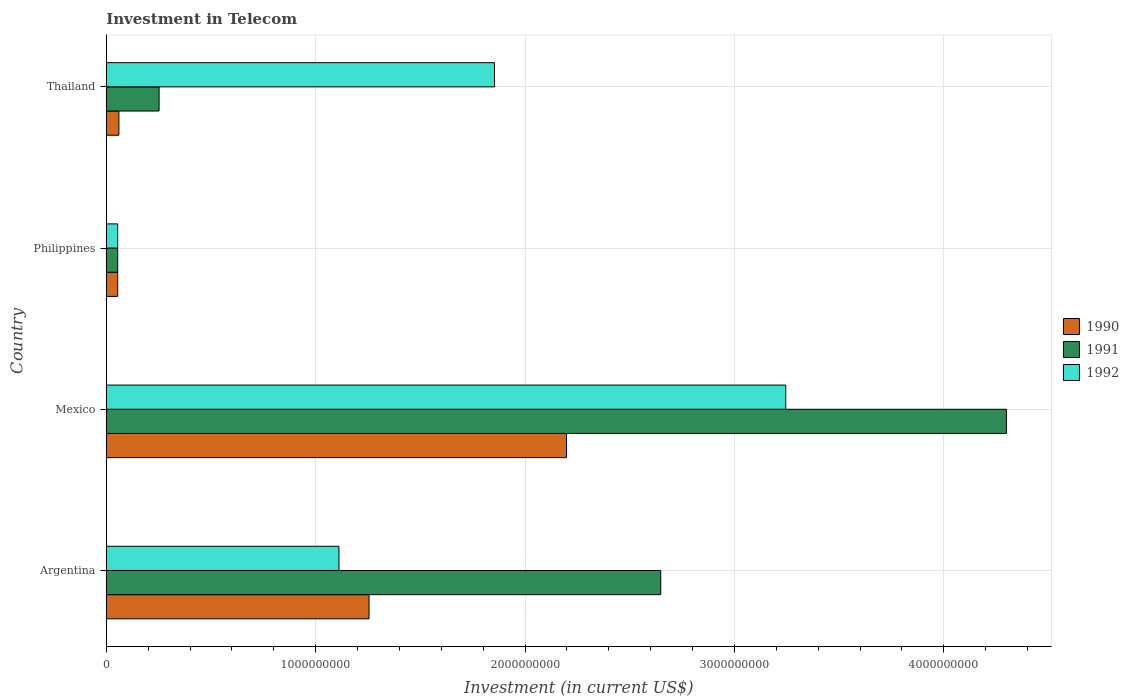How many different coloured bars are there?
Provide a succinct answer. 3. Are the number of bars on each tick of the Y-axis equal?
Keep it short and to the point. Yes. How many bars are there on the 2nd tick from the bottom?
Your response must be concise. 3. What is the label of the 1st group of bars from the top?
Give a very brief answer. Thailand. What is the amount invested in telecom in 1990 in Mexico?
Keep it short and to the point. 2.20e+09. Across all countries, what is the maximum amount invested in telecom in 1991?
Ensure brevity in your answer.  4.30e+09. Across all countries, what is the minimum amount invested in telecom in 1991?
Provide a short and direct response. 5.42e+07. In which country was the amount invested in telecom in 1990 maximum?
Make the answer very short. Mexico. What is the total amount invested in telecom in 1991 in the graph?
Offer a very short reply. 7.25e+09. What is the difference between the amount invested in telecom in 1992 in Mexico and that in Thailand?
Ensure brevity in your answer.  1.39e+09. What is the difference between the amount invested in telecom in 1992 in Argentina and the amount invested in telecom in 1991 in Mexico?
Your answer should be very brief. -3.19e+09. What is the average amount invested in telecom in 1990 per country?
Provide a succinct answer. 8.92e+08. What is the difference between the amount invested in telecom in 1992 and amount invested in telecom in 1990 in Philippines?
Your answer should be compact. 0. What is the ratio of the amount invested in telecom in 1992 in Argentina to that in Mexico?
Ensure brevity in your answer.  0.34. Is the difference between the amount invested in telecom in 1992 in Philippines and Thailand greater than the difference between the amount invested in telecom in 1990 in Philippines and Thailand?
Your answer should be very brief. No. What is the difference between the highest and the second highest amount invested in telecom in 1991?
Your answer should be compact. 1.65e+09. What is the difference between the highest and the lowest amount invested in telecom in 1990?
Give a very brief answer. 2.14e+09. In how many countries, is the amount invested in telecom in 1992 greater than the average amount invested in telecom in 1992 taken over all countries?
Your response must be concise. 2. What does the 1st bar from the bottom in Philippines represents?
Offer a very short reply. 1990. Are all the bars in the graph horizontal?
Ensure brevity in your answer.  Yes. How many countries are there in the graph?
Keep it short and to the point. 4. Are the values on the major ticks of X-axis written in scientific E-notation?
Keep it short and to the point. No. Does the graph contain any zero values?
Your answer should be compact. No. Does the graph contain grids?
Make the answer very short. Yes. Where does the legend appear in the graph?
Offer a terse response. Center right. How are the legend labels stacked?
Provide a short and direct response. Vertical. What is the title of the graph?
Make the answer very short. Investment in Telecom. Does "1963" appear as one of the legend labels in the graph?
Provide a succinct answer. No. What is the label or title of the X-axis?
Provide a short and direct response. Investment (in current US$). What is the label or title of the Y-axis?
Your response must be concise. Country. What is the Investment (in current US$) of 1990 in Argentina?
Your answer should be compact. 1.25e+09. What is the Investment (in current US$) of 1991 in Argentina?
Provide a short and direct response. 2.65e+09. What is the Investment (in current US$) in 1992 in Argentina?
Make the answer very short. 1.11e+09. What is the Investment (in current US$) in 1990 in Mexico?
Your response must be concise. 2.20e+09. What is the Investment (in current US$) of 1991 in Mexico?
Give a very brief answer. 4.30e+09. What is the Investment (in current US$) of 1992 in Mexico?
Offer a terse response. 3.24e+09. What is the Investment (in current US$) in 1990 in Philippines?
Keep it short and to the point. 5.42e+07. What is the Investment (in current US$) in 1991 in Philippines?
Provide a short and direct response. 5.42e+07. What is the Investment (in current US$) in 1992 in Philippines?
Your answer should be compact. 5.42e+07. What is the Investment (in current US$) of 1990 in Thailand?
Give a very brief answer. 6.00e+07. What is the Investment (in current US$) of 1991 in Thailand?
Your answer should be very brief. 2.52e+08. What is the Investment (in current US$) in 1992 in Thailand?
Keep it short and to the point. 1.85e+09. Across all countries, what is the maximum Investment (in current US$) in 1990?
Offer a terse response. 2.20e+09. Across all countries, what is the maximum Investment (in current US$) of 1991?
Provide a short and direct response. 4.30e+09. Across all countries, what is the maximum Investment (in current US$) of 1992?
Your answer should be very brief. 3.24e+09. Across all countries, what is the minimum Investment (in current US$) of 1990?
Your answer should be compact. 5.42e+07. Across all countries, what is the minimum Investment (in current US$) of 1991?
Ensure brevity in your answer.  5.42e+07. Across all countries, what is the minimum Investment (in current US$) of 1992?
Offer a very short reply. 5.42e+07. What is the total Investment (in current US$) of 1990 in the graph?
Offer a terse response. 3.57e+09. What is the total Investment (in current US$) in 1991 in the graph?
Your answer should be compact. 7.25e+09. What is the total Investment (in current US$) of 1992 in the graph?
Provide a short and direct response. 6.26e+09. What is the difference between the Investment (in current US$) in 1990 in Argentina and that in Mexico?
Provide a short and direct response. -9.43e+08. What is the difference between the Investment (in current US$) of 1991 in Argentina and that in Mexico?
Your answer should be compact. -1.65e+09. What is the difference between the Investment (in current US$) of 1992 in Argentina and that in Mexico?
Your response must be concise. -2.13e+09. What is the difference between the Investment (in current US$) of 1990 in Argentina and that in Philippines?
Keep it short and to the point. 1.20e+09. What is the difference between the Investment (in current US$) in 1991 in Argentina and that in Philippines?
Provide a short and direct response. 2.59e+09. What is the difference between the Investment (in current US$) in 1992 in Argentina and that in Philippines?
Your answer should be compact. 1.06e+09. What is the difference between the Investment (in current US$) of 1990 in Argentina and that in Thailand?
Ensure brevity in your answer.  1.19e+09. What is the difference between the Investment (in current US$) in 1991 in Argentina and that in Thailand?
Provide a succinct answer. 2.40e+09. What is the difference between the Investment (in current US$) of 1992 in Argentina and that in Thailand?
Your answer should be very brief. -7.43e+08. What is the difference between the Investment (in current US$) in 1990 in Mexico and that in Philippines?
Your answer should be compact. 2.14e+09. What is the difference between the Investment (in current US$) in 1991 in Mexico and that in Philippines?
Your answer should be very brief. 4.24e+09. What is the difference between the Investment (in current US$) of 1992 in Mexico and that in Philippines?
Provide a succinct answer. 3.19e+09. What is the difference between the Investment (in current US$) in 1990 in Mexico and that in Thailand?
Offer a terse response. 2.14e+09. What is the difference between the Investment (in current US$) of 1991 in Mexico and that in Thailand?
Offer a terse response. 4.05e+09. What is the difference between the Investment (in current US$) in 1992 in Mexico and that in Thailand?
Your answer should be compact. 1.39e+09. What is the difference between the Investment (in current US$) in 1990 in Philippines and that in Thailand?
Your answer should be compact. -5.80e+06. What is the difference between the Investment (in current US$) in 1991 in Philippines and that in Thailand?
Your response must be concise. -1.98e+08. What is the difference between the Investment (in current US$) in 1992 in Philippines and that in Thailand?
Offer a very short reply. -1.80e+09. What is the difference between the Investment (in current US$) in 1990 in Argentina and the Investment (in current US$) in 1991 in Mexico?
Ensure brevity in your answer.  -3.04e+09. What is the difference between the Investment (in current US$) of 1990 in Argentina and the Investment (in current US$) of 1992 in Mexico?
Provide a succinct answer. -1.99e+09. What is the difference between the Investment (in current US$) of 1991 in Argentina and the Investment (in current US$) of 1992 in Mexico?
Offer a very short reply. -5.97e+08. What is the difference between the Investment (in current US$) in 1990 in Argentina and the Investment (in current US$) in 1991 in Philippines?
Provide a short and direct response. 1.20e+09. What is the difference between the Investment (in current US$) of 1990 in Argentina and the Investment (in current US$) of 1992 in Philippines?
Make the answer very short. 1.20e+09. What is the difference between the Investment (in current US$) of 1991 in Argentina and the Investment (in current US$) of 1992 in Philippines?
Your answer should be compact. 2.59e+09. What is the difference between the Investment (in current US$) of 1990 in Argentina and the Investment (in current US$) of 1991 in Thailand?
Your answer should be very brief. 1.00e+09. What is the difference between the Investment (in current US$) of 1990 in Argentina and the Investment (in current US$) of 1992 in Thailand?
Offer a terse response. -5.99e+08. What is the difference between the Investment (in current US$) in 1991 in Argentina and the Investment (in current US$) in 1992 in Thailand?
Your response must be concise. 7.94e+08. What is the difference between the Investment (in current US$) of 1990 in Mexico and the Investment (in current US$) of 1991 in Philippines?
Give a very brief answer. 2.14e+09. What is the difference between the Investment (in current US$) of 1990 in Mexico and the Investment (in current US$) of 1992 in Philippines?
Ensure brevity in your answer.  2.14e+09. What is the difference between the Investment (in current US$) of 1991 in Mexico and the Investment (in current US$) of 1992 in Philippines?
Offer a terse response. 4.24e+09. What is the difference between the Investment (in current US$) of 1990 in Mexico and the Investment (in current US$) of 1991 in Thailand?
Offer a terse response. 1.95e+09. What is the difference between the Investment (in current US$) in 1990 in Mexico and the Investment (in current US$) in 1992 in Thailand?
Provide a short and direct response. 3.44e+08. What is the difference between the Investment (in current US$) of 1991 in Mexico and the Investment (in current US$) of 1992 in Thailand?
Keep it short and to the point. 2.44e+09. What is the difference between the Investment (in current US$) of 1990 in Philippines and the Investment (in current US$) of 1991 in Thailand?
Provide a succinct answer. -1.98e+08. What is the difference between the Investment (in current US$) in 1990 in Philippines and the Investment (in current US$) in 1992 in Thailand?
Ensure brevity in your answer.  -1.80e+09. What is the difference between the Investment (in current US$) in 1991 in Philippines and the Investment (in current US$) in 1992 in Thailand?
Your response must be concise. -1.80e+09. What is the average Investment (in current US$) in 1990 per country?
Offer a very short reply. 8.92e+08. What is the average Investment (in current US$) in 1991 per country?
Your answer should be compact. 1.81e+09. What is the average Investment (in current US$) of 1992 per country?
Your answer should be very brief. 1.57e+09. What is the difference between the Investment (in current US$) of 1990 and Investment (in current US$) of 1991 in Argentina?
Your answer should be very brief. -1.39e+09. What is the difference between the Investment (in current US$) in 1990 and Investment (in current US$) in 1992 in Argentina?
Your answer should be very brief. 1.44e+08. What is the difference between the Investment (in current US$) of 1991 and Investment (in current US$) of 1992 in Argentina?
Make the answer very short. 1.54e+09. What is the difference between the Investment (in current US$) in 1990 and Investment (in current US$) in 1991 in Mexico?
Offer a very short reply. -2.10e+09. What is the difference between the Investment (in current US$) in 1990 and Investment (in current US$) in 1992 in Mexico?
Offer a terse response. -1.05e+09. What is the difference between the Investment (in current US$) of 1991 and Investment (in current US$) of 1992 in Mexico?
Keep it short and to the point. 1.05e+09. What is the difference between the Investment (in current US$) in 1990 and Investment (in current US$) in 1992 in Philippines?
Your answer should be compact. 0. What is the difference between the Investment (in current US$) in 1990 and Investment (in current US$) in 1991 in Thailand?
Keep it short and to the point. -1.92e+08. What is the difference between the Investment (in current US$) of 1990 and Investment (in current US$) of 1992 in Thailand?
Keep it short and to the point. -1.79e+09. What is the difference between the Investment (in current US$) in 1991 and Investment (in current US$) in 1992 in Thailand?
Provide a short and direct response. -1.60e+09. What is the ratio of the Investment (in current US$) in 1990 in Argentina to that in Mexico?
Offer a terse response. 0.57. What is the ratio of the Investment (in current US$) in 1991 in Argentina to that in Mexico?
Give a very brief answer. 0.62. What is the ratio of the Investment (in current US$) in 1992 in Argentina to that in Mexico?
Make the answer very short. 0.34. What is the ratio of the Investment (in current US$) of 1990 in Argentina to that in Philippines?
Your answer should be very brief. 23.15. What is the ratio of the Investment (in current US$) of 1991 in Argentina to that in Philippines?
Give a very brief answer. 48.86. What is the ratio of the Investment (in current US$) of 1992 in Argentina to that in Philippines?
Your answer should be compact. 20.5. What is the ratio of the Investment (in current US$) of 1990 in Argentina to that in Thailand?
Offer a terse response. 20.91. What is the ratio of the Investment (in current US$) of 1991 in Argentina to that in Thailand?
Ensure brevity in your answer.  10.51. What is the ratio of the Investment (in current US$) in 1992 in Argentina to that in Thailand?
Offer a terse response. 0.6. What is the ratio of the Investment (in current US$) of 1990 in Mexico to that in Philippines?
Make the answer very short. 40.55. What is the ratio of the Investment (in current US$) of 1991 in Mexico to that in Philippines?
Your answer should be very brief. 79.32. What is the ratio of the Investment (in current US$) of 1992 in Mexico to that in Philippines?
Offer a terse response. 59.87. What is the ratio of the Investment (in current US$) of 1990 in Mexico to that in Thailand?
Provide a short and direct response. 36.63. What is the ratio of the Investment (in current US$) of 1991 in Mexico to that in Thailand?
Offer a terse response. 17.06. What is the ratio of the Investment (in current US$) in 1992 in Mexico to that in Thailand?
Offer a terse response. 1.75. What is the ratio of the Investment (in current US$) of 1990 in Philippines to that in Thailand?
Keep it short and to the point. 0.9. What is the ratio of the Investment (in current US$) of 1991 in Philippines to that in Thailand?
Provide a succinct answer. 0.22. What is the ratio of the Investment (in current US$) of 1992 in Philippines to that in Thailand?
Offer a very short reply. 0.03. What is the difference between the highest and the second highest Investment (in current US$) of 1990?
Offer a very short reply. 9.43e+08. What is the difference between the highest and the second highest Investment (in current US$) in 1991?
Your answer should be compact. 1.65e+09. What is the difference between the highest and the second highest Investment (in current US$) in 1992?
Provide a short and direct response. 1.39e+09. What is the difference between the highest and the lowest Investment (in current US$) in 1990?
Keep it short and to the point. 2.14e+09. What is the difference between the highest and the lowest Investment (in current US$) in 1991?
Ensure brevity in your answer.  4.24e+09. What is the difference between the highest and the lowest Investment (in current US$) in 1992?
Provide a short and direct response. 3.19e+09. 